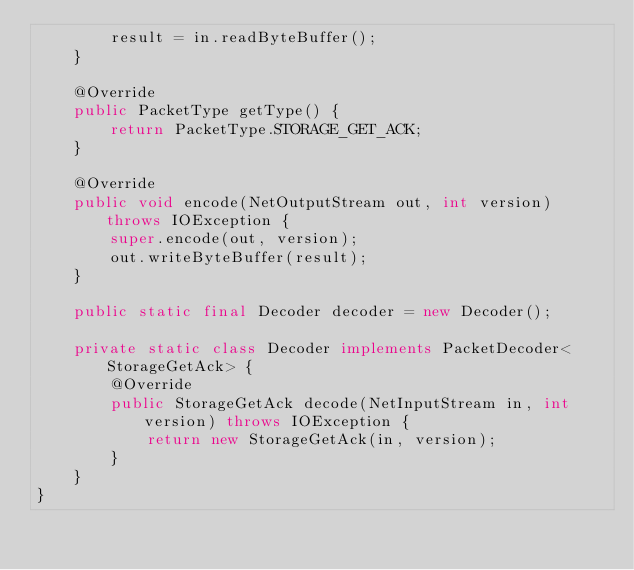<code> <loc_0><loc_0><loc_500><loc_500><_Java_>        result = in.readByteBuffer();
    }

    @Override
    public PacketType getType() {
        return PacketType.STORAGE_GET_ACK;
    }

    @Override
    public void encode(NetOutputStream out, int version) throws IOException {
        super.encode(out, version);
        out.writeByteBuffer(result);
    }

    public static final Decoder decoder = new Decoder();

    private static class Decoder implements PacketDecoder<StorageGetAck> {
        @Override
        public StorageGetAck decode(NetInputStream in, int version) throws IOException {
            return new StorageGetAck(in, version);
        }
    }
}
</code> 